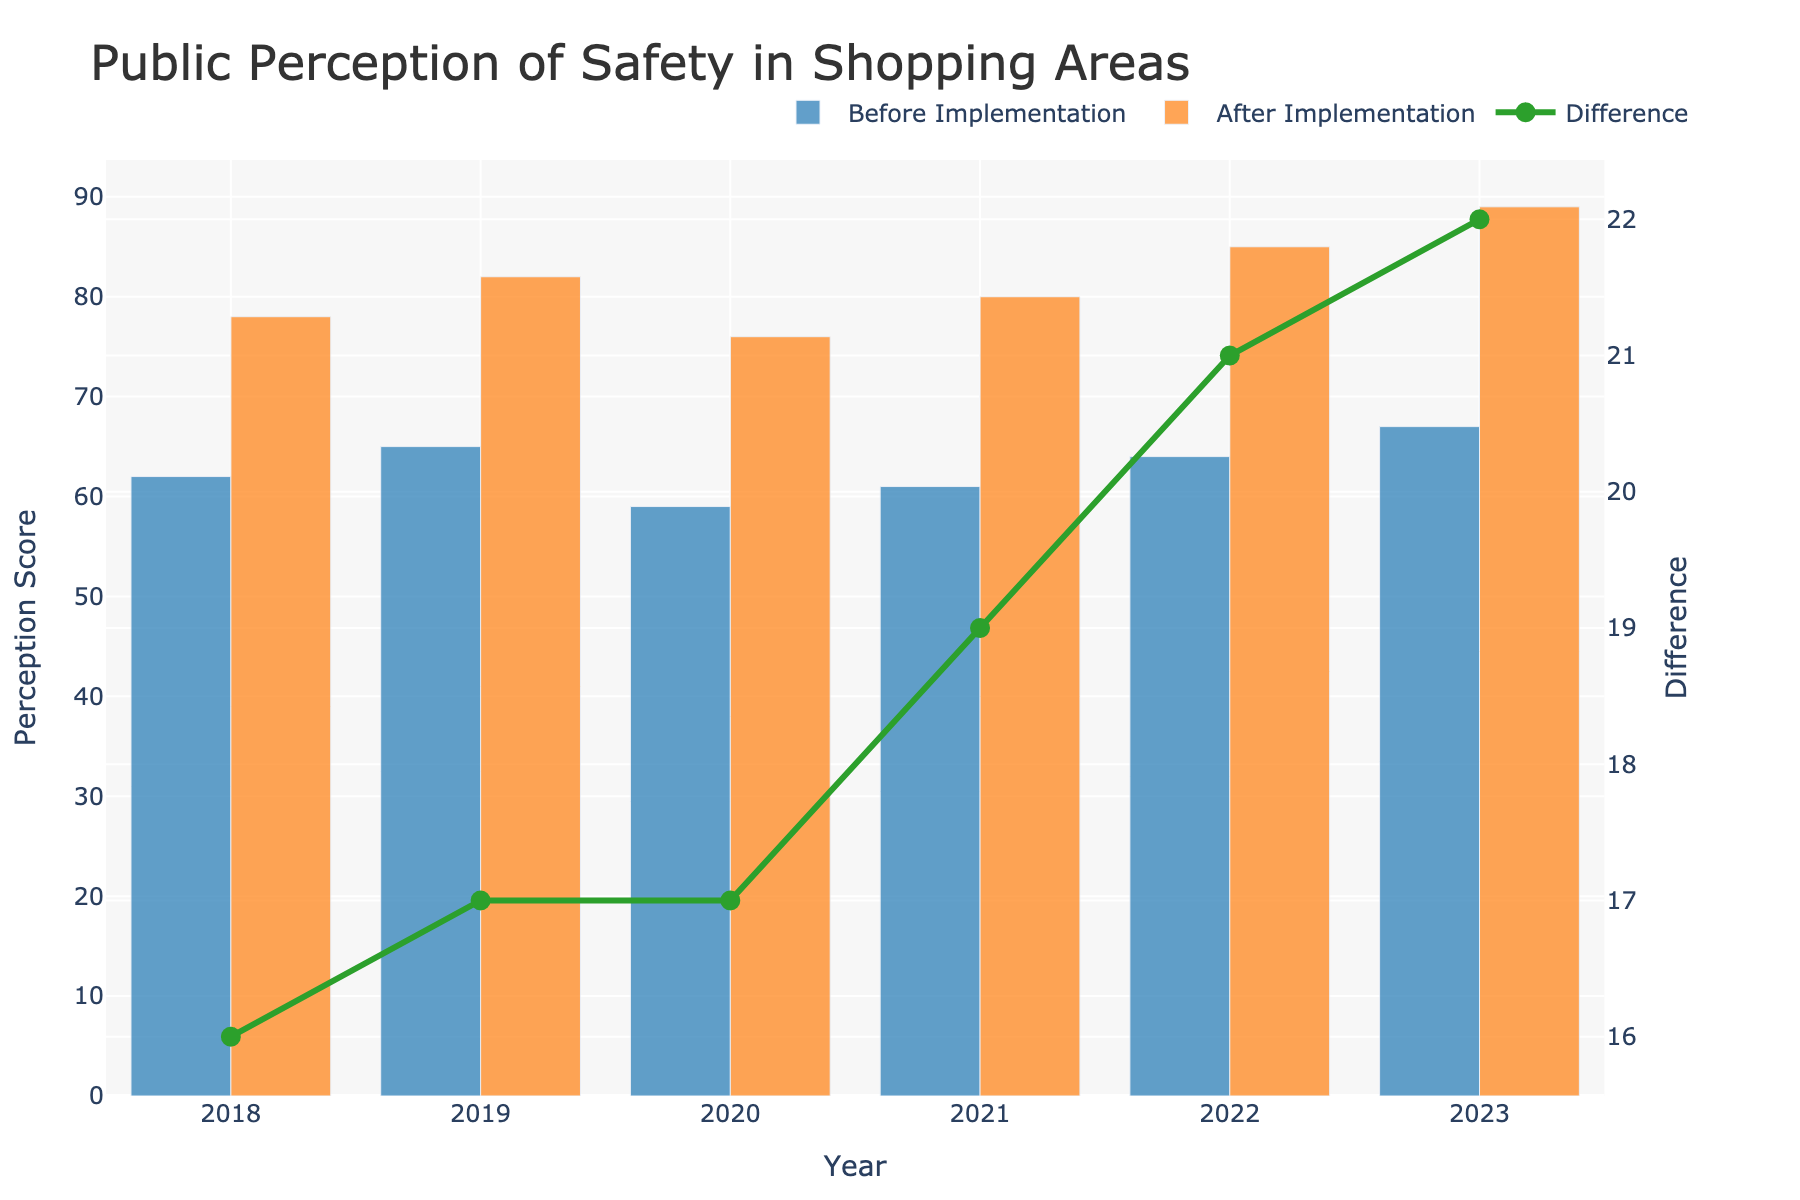What year shows the highest public perception of safety after security measures were implemented? The highest bar for 'After Implementation' indicates the year 2023.
Answer: 2023 Which year had the smallest difference in public perception of safety before and after the implementation? The line for 'Difference' is lowest in 2020, indicating the smallest gap between before and after implementation.
Answer: 2020 How much did the public perception of safety improve from 2022 to 2023 after the implementation of security measures? The 'After Implementation' values for 2022 and 2023 are 85 and 89, respectively, so the improvement is 89 - 85 = 4 points.
Answer: 4 In which years was the public perception of safety before the implementation of security measures higher than 60? The bars for 'Before Implementation' are above 60 in the years 2018, 2019, 2021, 2022, and 2023.
Answer: 2018, 2019, 2021, 2022, 2023 What is the average public perception of safety after the implementation over the given years? Sum the 'After Implementation' values (78 + 82 + 76 + 80 + 85 + 89) = 490, and divide by the number of years (6), giving 490 / 6 = approximately 81.67.
Answer: ~81.67 Compare the increase in public perception of safety from 'Before Implementation' to 'After Implementation' for 2018 and 2019. Which year had a greater increase? For 2018, the increase is 78 - 62 = 16. For 2019, it is 82 - 65 = 17. 2019 had a greater increase.
Answer: 2019 What visual feature helps to determine the difference in public perception of safety before and after the implementation of security measures? The green line plot named 'Difference' shows the change directly by indicating the value difference between 'Before Implementation' and 'After Implementation'.
Answer: The green line plot Which year had the largest improvement in public perception of safety after implementation of security measures? The peak of the green line, representing the difference, is highest in 2023.
Answer: 2023 